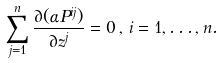Convert formula to latex. <formula><loc_0><loc_0><loc_500><loc_500>\sum _ { j = 1 } ^ { n } \frac { \partial ( \alpha P ^ { i j } ) } { \partial z ^ { j } } = 0 \, , \, i = 1 , \dots , n .</formula> 